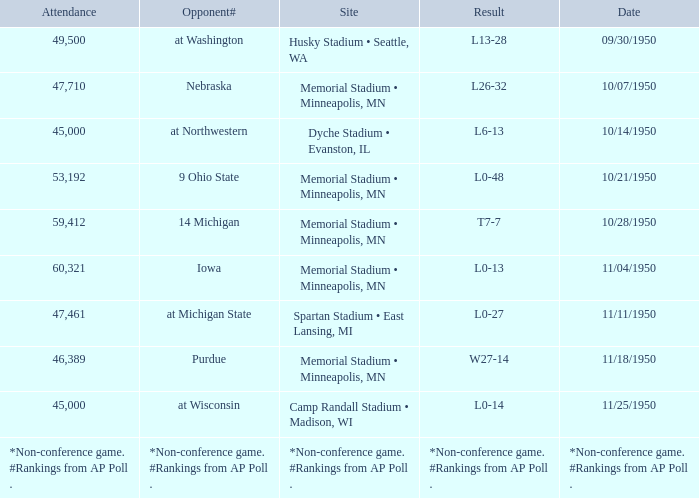What is the Date when the result is *non-conference game. #rankings from ap poll .? *Non-conference game. #Rankings from AP Poll . 